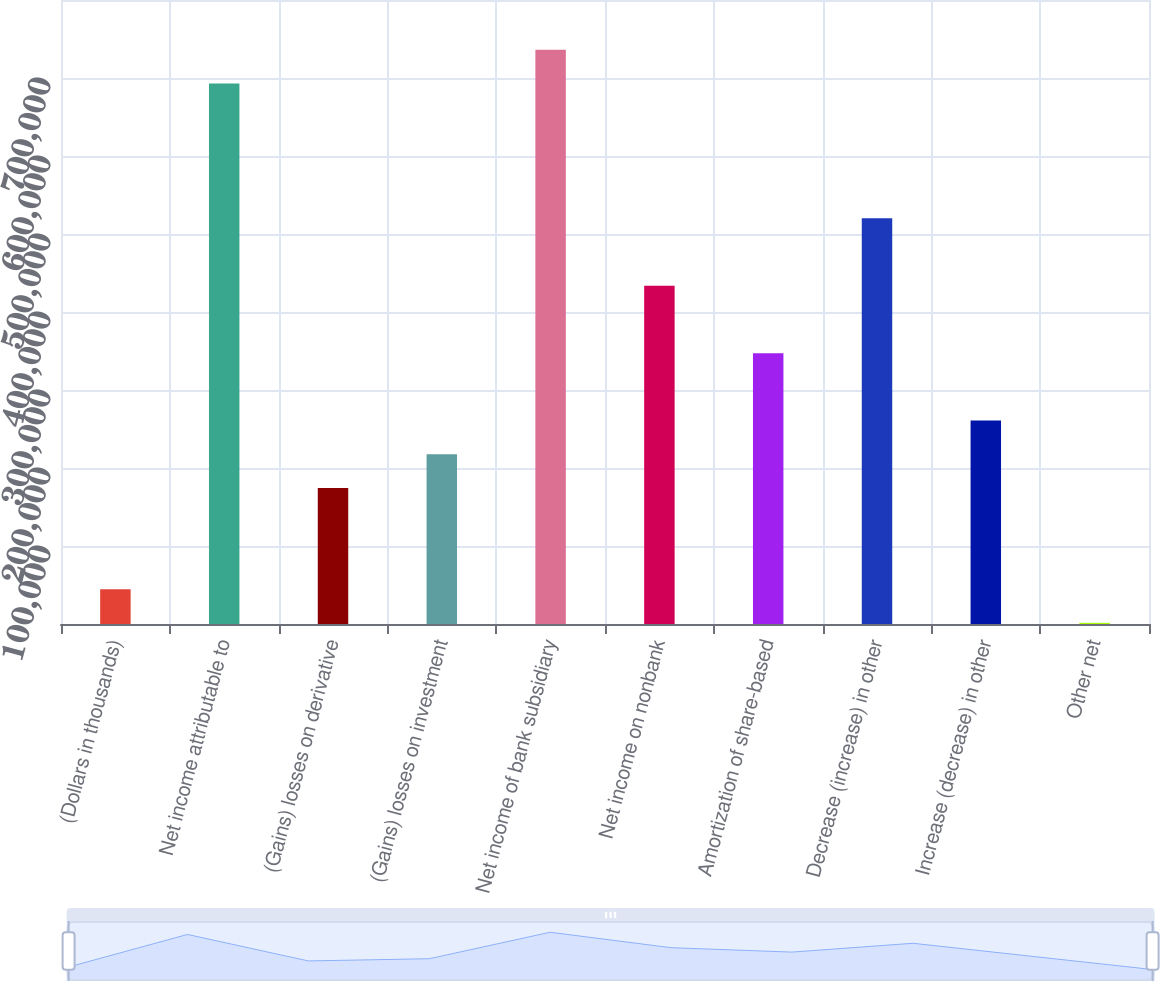<chart> <loc_0><loc_0><loc_500><loc_500><bar_chart><fcel>(Dollars in thousands)<fcel>Net income attributable to<fcel>(Gains) losses on derivative<fcel>(Gains) losses on investment<fcel>Net income of bank subsidiary<fcel>Net income on nonbank<fcel>Amortization of share-based<fcel>Decrease (increase) in other<fcel>Increase (decrease) in other<fcel>Other net<nl><fcel>44684.6<fcel>692979<fcel>174343<fcel>217563<fcel>736198<fcel>433661<fcel>347222<fcel>520100<fcel>260783<fcel>1465<nl></chart> 